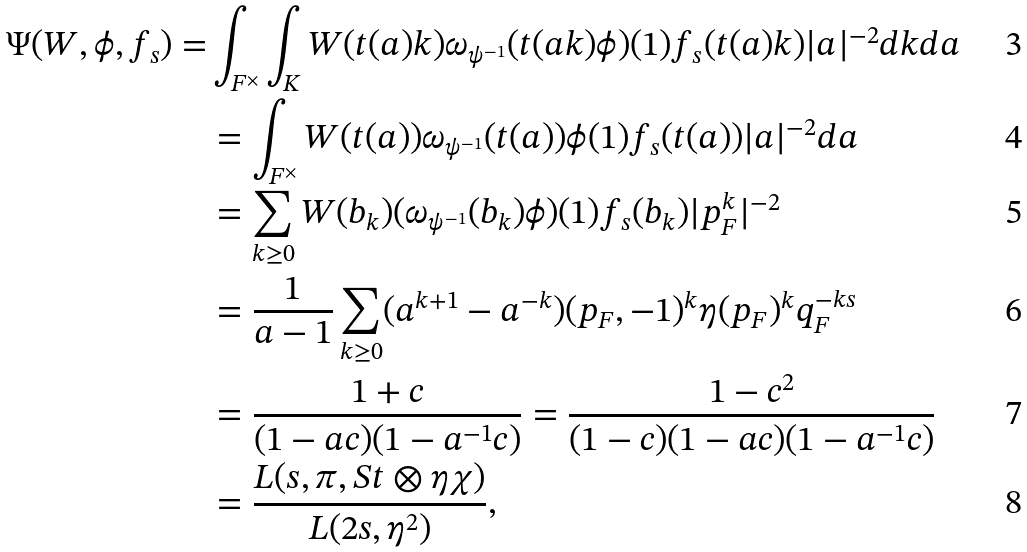Convert formula to latex. <formula><loc_0><loc_0><loc_500><loc_500>\Psi ( W , \phi , f _ { s } ) = & \int _ { F ^ { \times } } \int _ { K } W ( t ( a ) k ) \omega _ { \psi ^ { - 1 } } ( t ( a k ) \phi ) ( 1 ) f _ { s } ( t ( a ) k ) | a | ^ { - 2 } d k d a \\ & = \int _ { F ^ { \times } } W ( t ( a ) ) \omega _ { \psi ^ { - 1 } } ( t ( a ) ) \phi ( 1 ) f _ { s } ( t ( a ) ) | a | ^ { - 2 } d a \\ & = \sum _ { k \geq 0 } W ( b _ { k } ) ( \omega _ { \psi ^ { - 1 } } ( b _ { k } ) \phi ) ( 1 ) f _ { s } ( b _ { k } ) | p _ { F } ^ { k } | ^ { - 2 } \\ & = \frac { 1 } { a - 1 } \sum _ { k \geq 0 } ( a ^ { k + 1 } - a ^ { - k } ) ( p _ { F } , - 1 ) ^ { k } \eta ( p _ { F } ) ^ { k } q _ { F } ^ { - k s } \\ & = \frac { 1 + c } { ( 1 - a c ) ( 1 - a ^ { - 1 } c ) } = \frac { 1 - c ^ { 2 } } { ( 1 - c ) ( 1 - a c ) ( 1 - a ^ { - 1 } c ) } \\ & = \frac { L ( s , \pi , S t \otimes \eta \chi ) } { L ( 2 s , \eta ^ { 2 } ) } ,</formula> 